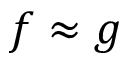<formula> <loc_0><loc_0><loc_500><loc_500>f \approx g</formula> 